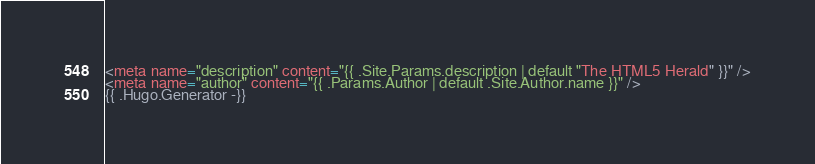Convert code to text. <code><loc_0><loc_0><loc_500><loc_500><_HTML_><meta name="description" content="{{ .Site.Params.description | default "The HTML5 Herald" }}" />
<meta name="author" content="{{ .Params.Author | default .Site.Author.name }}" />
{{ .Hugo.Generator -}}
</code> 